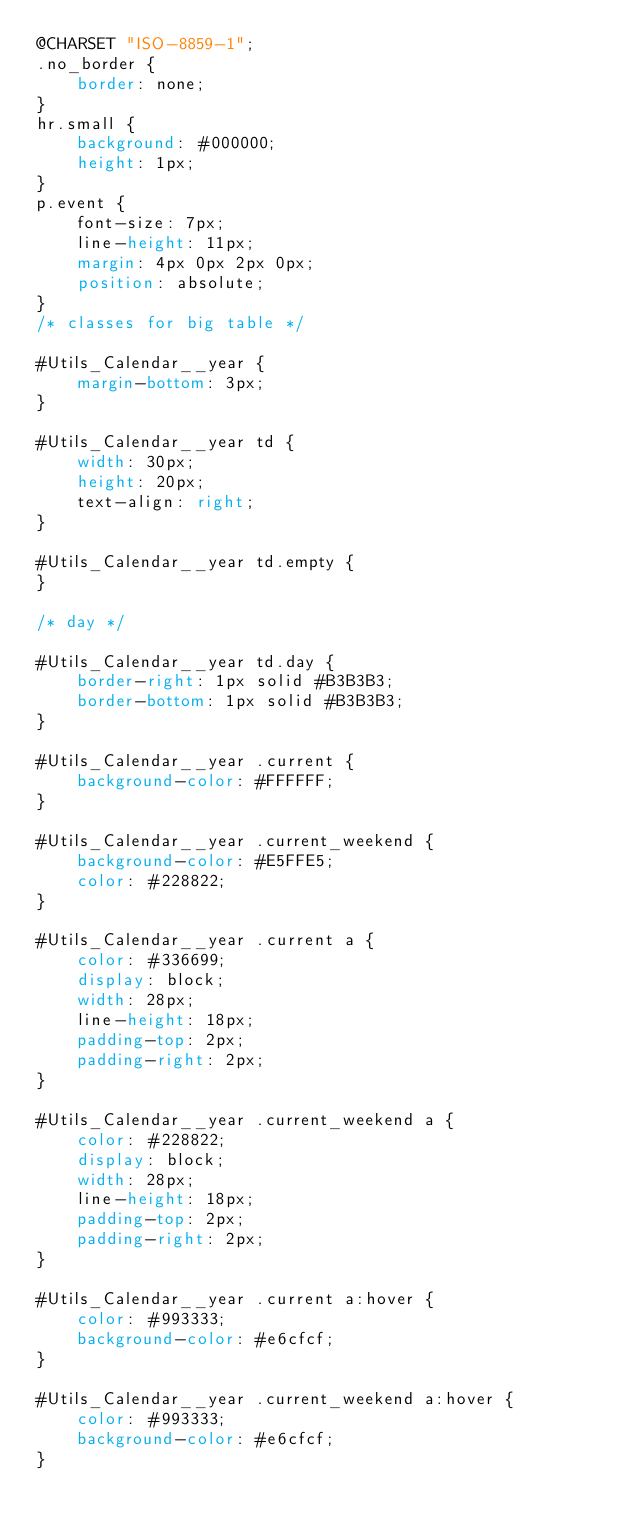<code> <loc_0><loc_0><loc_500><loc_500><_CSS_>@CHARSET "ISO-8859-1";
.no_border {
	border: none;
}
hr.small {
	background: #000000;
	height: 1px;
}
p.event {
	font-size: 7px;
	line-height: 11px;
	margin: 4px 0px 2px 0px;
	position: absolute;
}
/* classes for big table */

#Utils_Calendar__year {
	margin-bottom: 3px;
}

#Utils_Calendar__year td {
	width: 30px;
	height: 20px;
	text-align: right;
}

#Utils_Calendar__year td.empty {
}

/* day */

#Utils_Calendar__year td.day {
	border-right: 1px solid #B3B3B3;
	border-bottom: 1px solid #B3B3B3;
}

#Utils_Calendar__year .current {
	background-color: #FFFFFF;
}

#Utils_Calendar__year .current_weekend {
	background-color: #E5FFE5;
	color: #228822;
}

#Utils_Calendar__year .current a {
	color: #336699;
	display: block;
	width: 28px;
	line-height: 18px;
	padding-top: 2px;
	padding-right: 2px;
}

#Utils_Calendar__year .current_weekend a {
	color: #228822;
	display: block;
	width: 28px;
	line-height: 18px;
	padding-top: 2px;
	padding-right: 2px;
}

#Utils_Calendar__year .current a:hover {
	color: #993333;
	background-color: #e6cfcf;
}

#Utils_Calendar__year .current_weekend a:hover {
	color: #993333;
	background-color: #e6cfcf;
}
</code> 